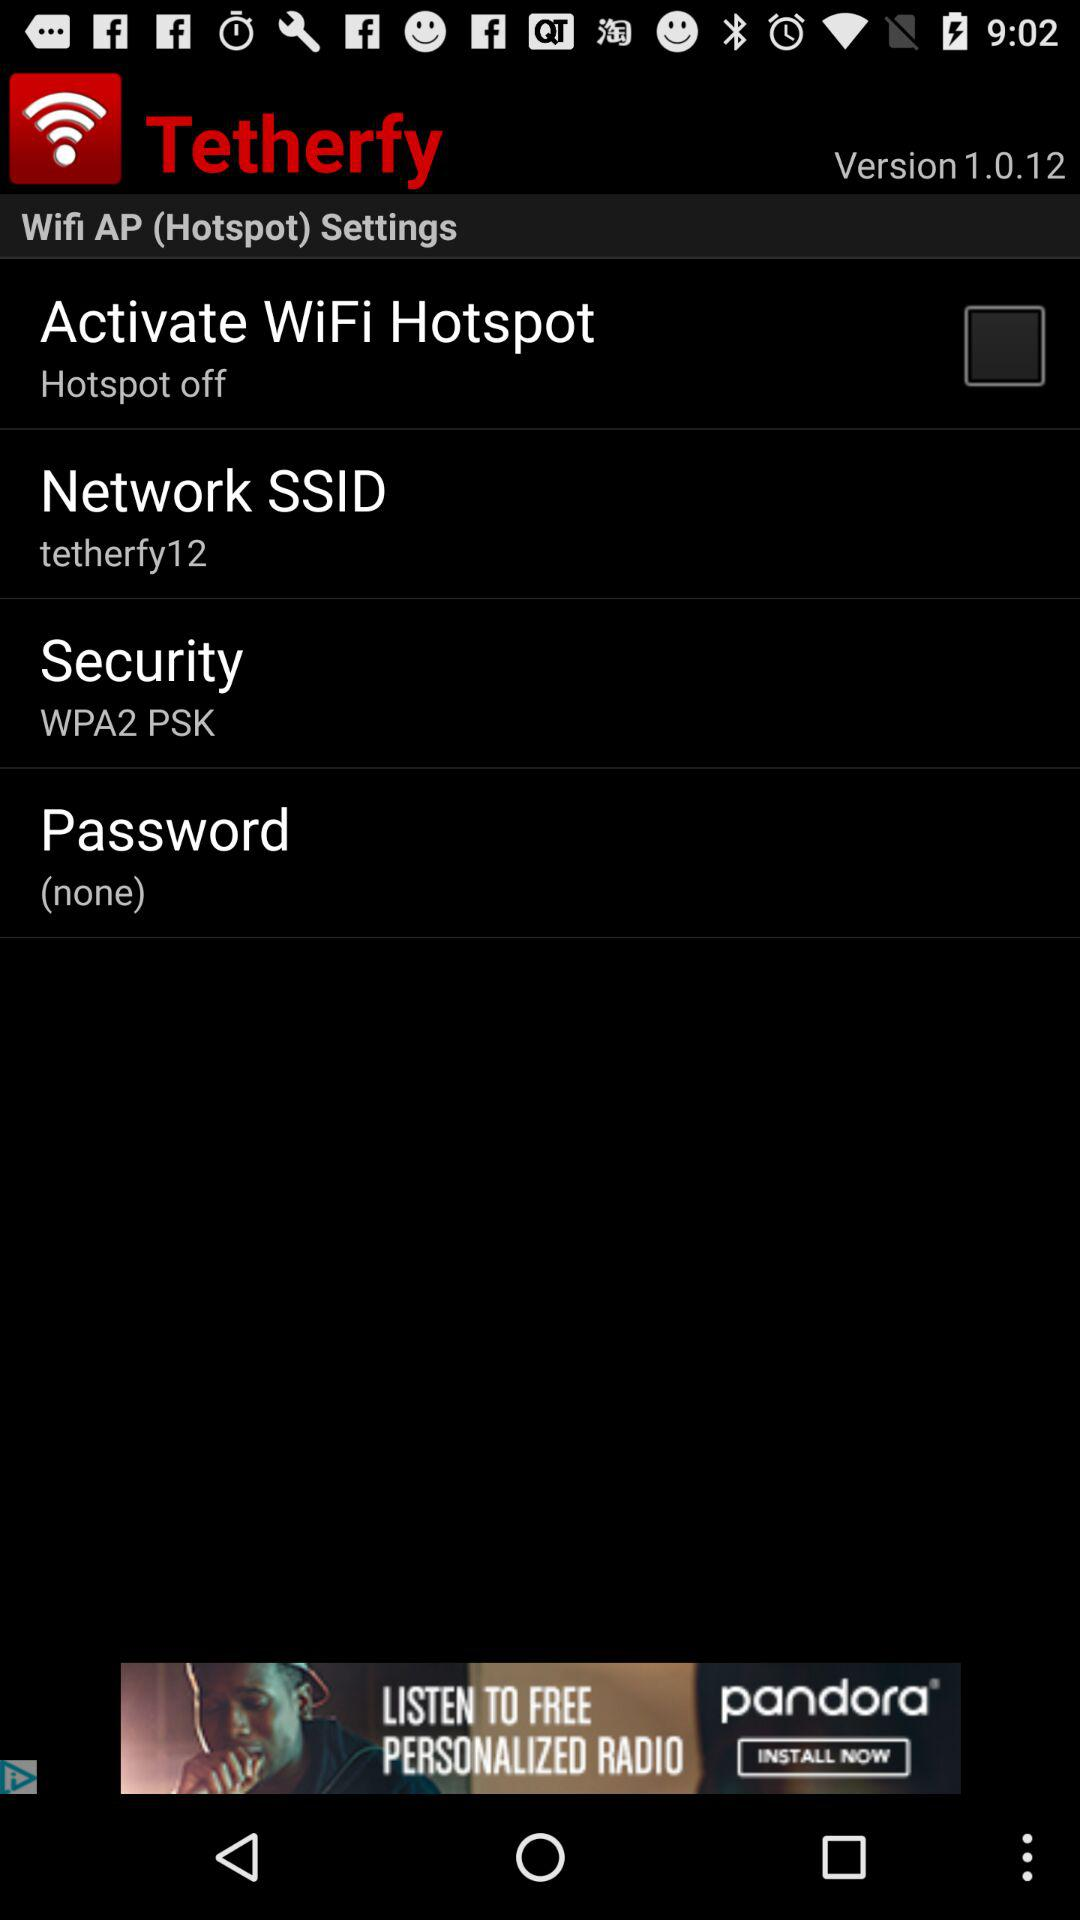What is the status of "Activate WiFi Hotspot"? The status of "Activate WiFi Hotspot" is "off". 